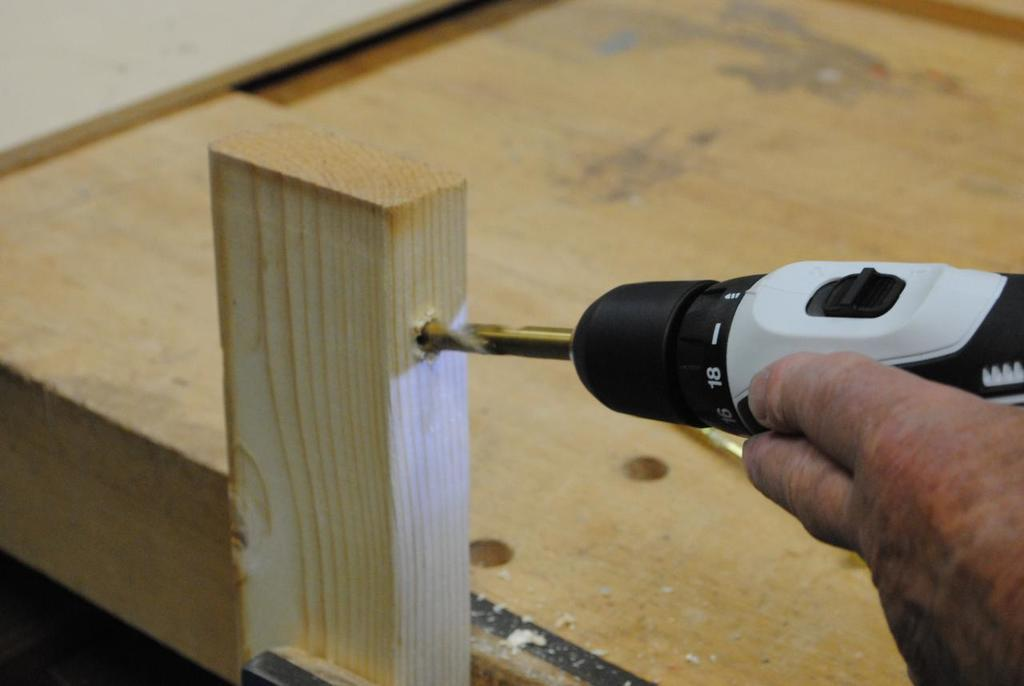What is the main subject of the image? There is a person in the image. What is the person doing in the image? The person is drilling wood. What tool is the person using to drill the wood? The person is using a drilling machine. What type of expansion is the person working on in the image? There is no mention of expansion in the image; the person is simply drilling wood. 